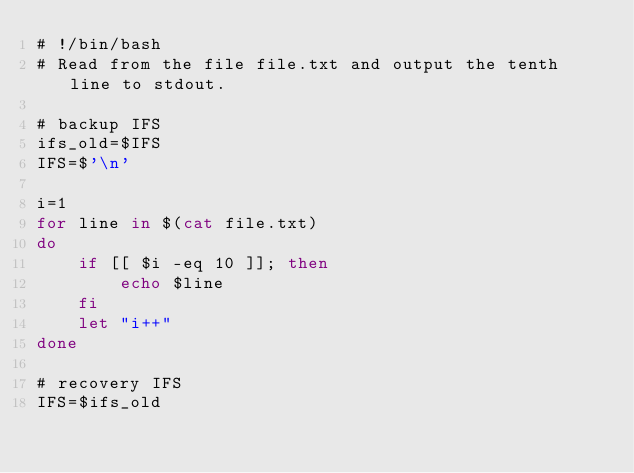<code> <loc_0><loc_0><loc_500><loc_500><_Bash_># !/bin/bash
# Read from the file file.txt and output the tenth line to stdout.

# backup IFS
ifs_old=$IFS
IFS=$'\n'

i=1
for line in $(cat file.txt)
do
    if [[ $i -eq 10 ]]; then
        echo $line
    fi
    let "i++"
done

# recovery IFS
IFS=$ifs_old</code> 